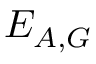<formula> <loc_0><loc_0><loc_500><loc_500>E _ { A , G }</formula> 